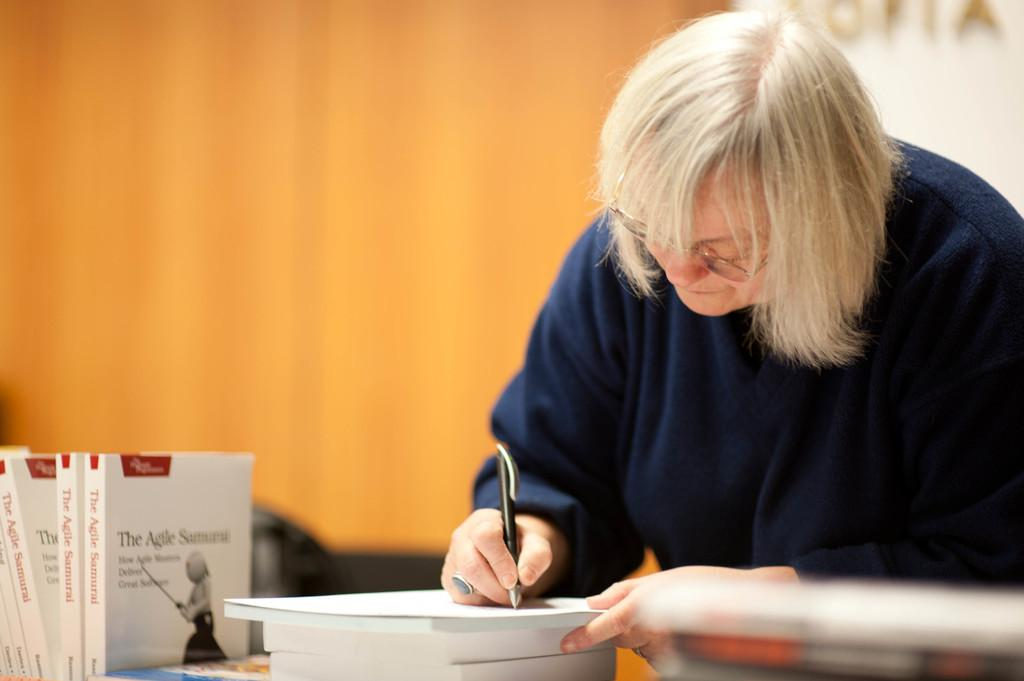<image>
Summarize the visual content of the image. A person with grey hair is writing on a pad of paper by a row of books called The Agile Samurai. 